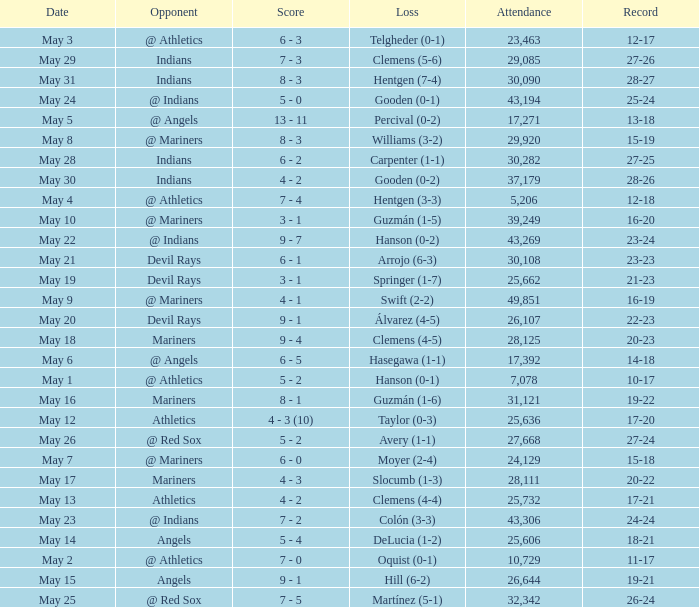I'm looking to parse the entire table for insights. Could you assist me with that? {'header': ['Date', 'Opponent', 'Score', 'Loss', 'Attendance', 'Record'], 'rows': [['May 3', '@ Athletics', '6 - 3', 'Telgheder (0-1)', '23,463', '12-17'], ['May 29', 'Indians', '7 - 3', 'Clemens (5-6)', '29,085', '27-26'], ['May 31', 'Indians', '8 - 3', 'Hentgen (7-4)', '30,090', '28-27'], ['May 24', '@ Indians', '5 - 0', 'Gooden (0-1)', '43,194', '25-24'], ['May 5', '@ Angels', '13 - 11', 'Percival (0-2)', '17,271', '13-18'], ['May 8', '@ Mariners', '8 - 3', 'Williams (3-2)', '29,920', '15-19'], ['May 28', 'Indians', '6 - 2', 'Carpenter (1-1)', '30,282', '27-25'], ['May 30', 'Indians', '4 - 2', 'Gooden (0-2)', '37,179', '28-26'], ['May 4', '@ Athletics', '7 - 4', 'Hentgen (3-3)', '5,206', '12-18'], ['May 10', '@ Mariners', '3 - 1', 'Guzmán (1-5)', '39,249', '16-20'], ['May 22', '@ Indians', '9 - 7', 'Hanson (0-2)', '43,269', '23-24'], ['May 21', 'Devil Rays', '6 - 1', 'Arrojo (6-3)', '30,108', '23-23'], ['May 19', 'Devil Rays', '3 - 1', 'Springer (1-7)', '25,662', '21-23'], ['May 9', '@ Mariners', '4 - 1', 'Swift (2-2)', '49,851', '16-19'], ['May 20', 'Devil Rays', '9 - 1', 'Álvarez (4-5)', '26,107', '22-23'], ['May 18', 'Mariners', '9 - 4', 'Clemens (4-5)', '28,125', '20-23'], ['May 6', '@ Angels', '6 - 5', 'Hasegawa (1-1)', '17,392', '14-18'], ['May 1', '@ Athletics', '5 - 2', 'Hanson (0-1)', '7,078', '10-17'], ['May 16', 'Mariners', '8 - 1', 'Guzmán (1-6)', '31,121', '19-22'], ['May 12', 'Athletics', '4 - 3 (10)', 'Taylor (0-3)', '25,636', '17-20'], ['May 26', '@ Red Sox', '5 - 2', 'Avery (1-1)', '27,668', '27-24'], ['May 7', '@ Mariners', '6 - 0', 'Moyer (2-4)', '24,129', '15-18'], ['May 17', 'Mariners', '4 - 3', 'Slocumb (1-3)', '28,111', '20-22'], ['May 13', 'Athletics', '4 - 2', 'Clemens (4-4)', '25,732', '17-21'], ['May 23', '@ Indians', '7 - 2', 'Colón (3-3)', '43,306', '24-24'], ['May 14', 'Angels', '5 - 4', 'DeLucia (1-2)', '25,606', '18-21'], ['May 2', '@ Athletics', '7 - 0', 'Oquist (0-1)', '10,729', '11-17'], ['May 15', 'Angels', '9 - 1', 'Hill (6-2)', '26,644', '19-21'], ['May 25', '@ Red Sox', '7 - 5', 'Martínez (5-1)', '32,342', '26-24']]} For record 25-24, what is the sum of attendance? 1.0. 